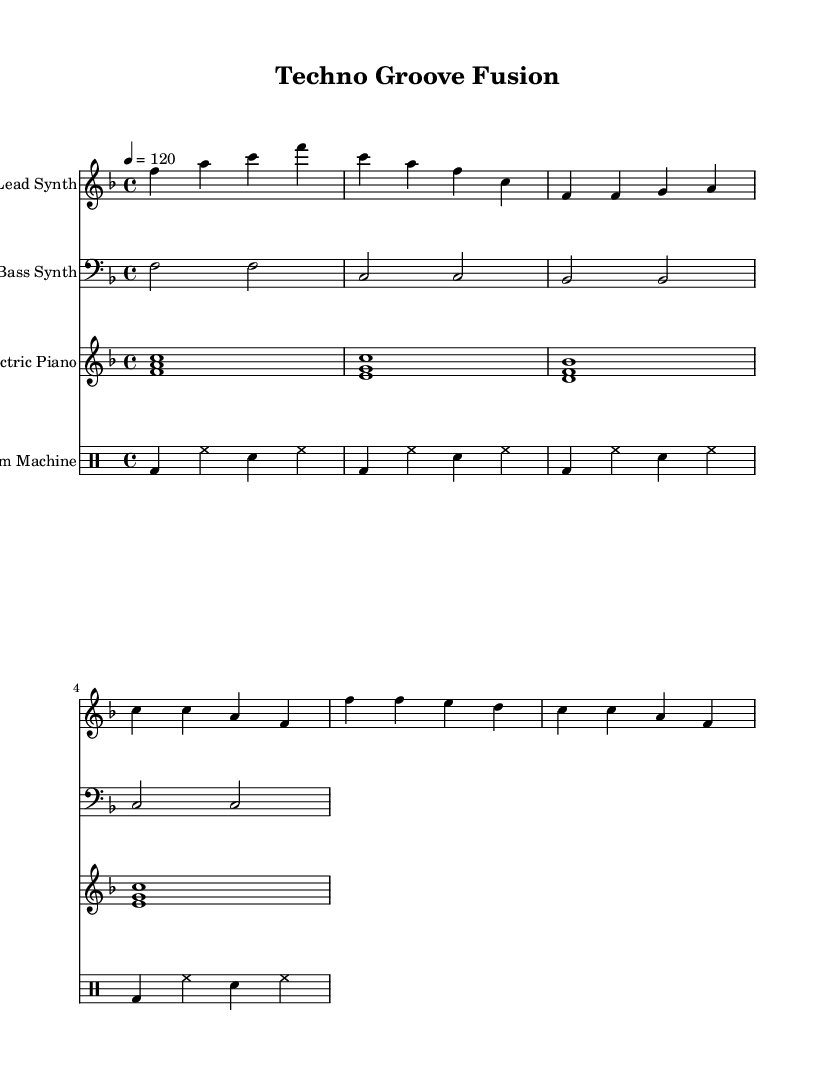What is the key signature of this music? The key signature is F major, which has one flat (B flat). This can be determined by looking at the key signature indicated at the beginning of the score.
Answer: F major What is the time signature of this music? The time signature is 4/4, as indicated right after the key signature. This means there are four beats per measure, and the quarter note gets one beat.
Answer: 4/4 What is the tempo marking for this piece? The tempo marking is 120 BPM (beats per minute), which is indicated by "4 = 120" at the beginning of the score. This tells us how fast to play the piece.
Answer: 120 How many measures are there in the lead synth part? There are 8 measures in the lead synth part, evident by counting the groupings of notes and the bar lines in the staff for this instrument.
Answer: 8 Which instruments are included in this piece? The instruments included are Lead Synth, Bass Synth, Electric Piano, and Drum Machine. You can see the names of the instruments at the beginning of each staff in the score.
Answer: Lead Synth, Bass Synth, Electric Piano, Drum Machine What is the instrument playing the bass line? The instrument playing the bass line is the Bass Synth, indicated clearly in the staff label for the bass clef portion of the score.
Answer: Bass Synth What type of electronic element is present in this R&B fusion? The electronic element present is synthesizers, which are represented by both the Lead Synth and Bass Synth in the score. This is typical for the upbeat R&B fusion style.
Answer: Synthesizers 